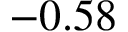Convert formula to latex. <formula><loc_0><loc_0><loc_500><loc_500>- 0 . 5 8</formula> 